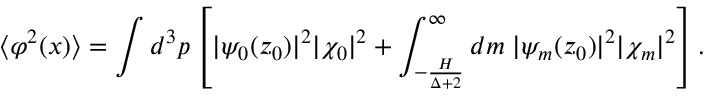<formula> <loc_0><loc_0><loc_500><loc_500>\langle \varphi ^ { 2 } ( x ) \rangle = \int d ^ { 3 } p \left [ | \psi _ { 0 } ( z _ { 0 } ) | ^ { 2 } | \chi _ { 0 } | ^ { 2 } + \int _ { - \frac { H } { \Delta + 2 } } ^ { \infty } d m \, | \psi _ { m } ( z _ { 0 } ) | ^ { 2 } | \chi _ { m } | ^ { 2 } \right ] .</formula> 